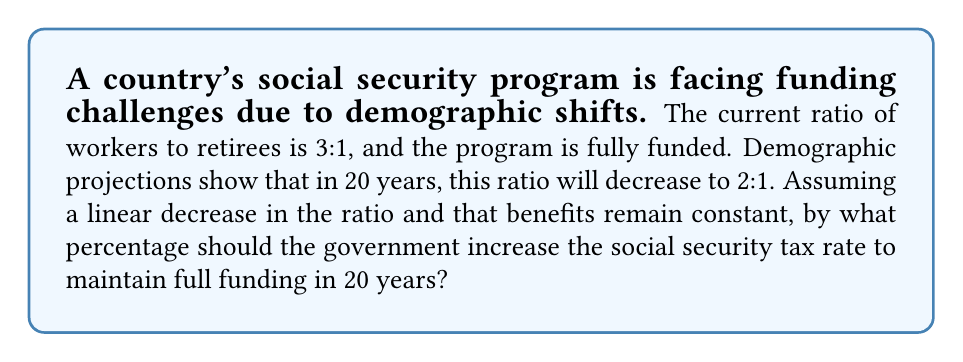Help me with this question. Let's approach this step-by-step:

1) Let the current tax rate be $x$.

2) With a 3:1 ratio of workers to retirees, each retiree's benefits are funded by 3x in taxes.

3) In 20 years, with a 2:1 ratio, each retiree's benefits will be funded by 2y in taxes, where y is the new tax rate.

4) For the program to remain fully funded, we need:

   $$3x = 2y$$

5) Solving for y:

   $$y = \frac{3x}{2}$$

6) The percentage increase is:

   $$\text{Percentage Increase} = \frac{y - x}{x} \times 100\%$$

7) Substituting $y = \frac{3x}{2}$:

   $$\text{Percentage Increase} = \frac{\frac{3x}{2} - x}{x} \times 100\%$$

8) Simplifying:

   $$\text{Percentage Increase} = \frac{\frac{x}{2}}{x} \times 100\% = \frac{1}{2} \times 100\% = 50\%$$

Therefore, the government should increase the social security tax rate by 50% to maintain full funding in 20 years.
Answer: 50% 